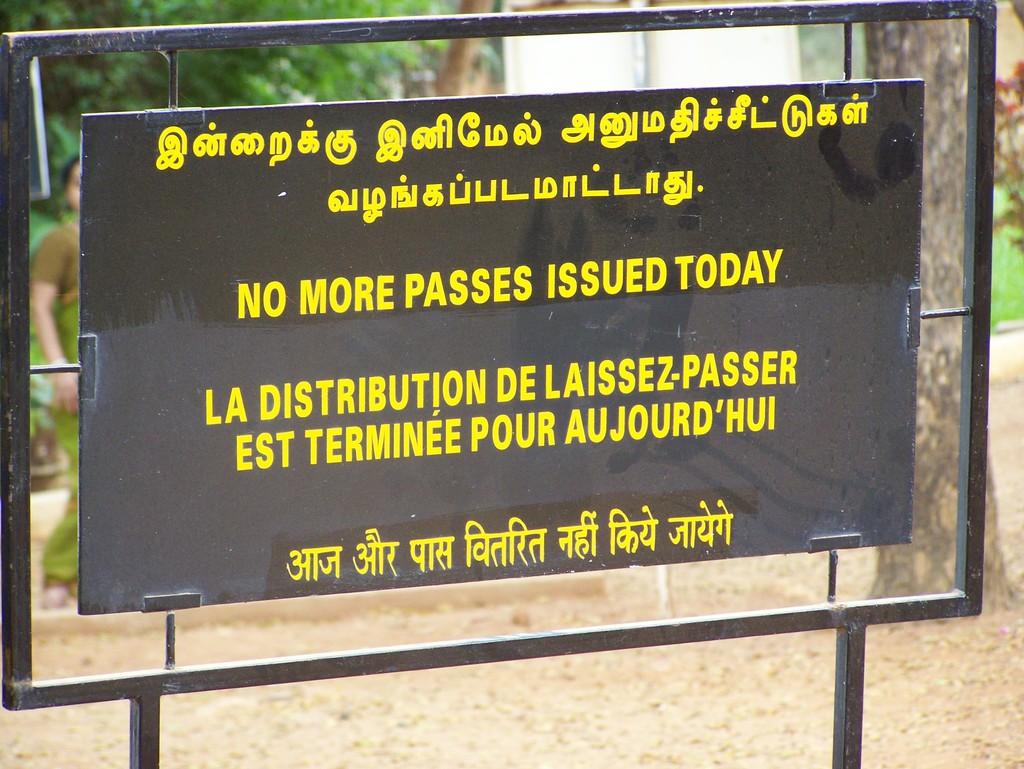What is not being issued today?
Provide a short and direct response. Passes. 